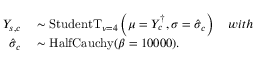Convert formula to latex. <formula><loc_0><loc_0><loc_500><loc_500>\begin{array} { r l } { Y _ { s , c } } & \sim S t u d e n t T _ { \nu = 4 } \left ( \mu = Y _ { c } ^ { \dagger } , \sigma = \hat { \sigma } _ { c } \right ) \quad w i t h } \\ { \hat { \sigma } _ { c } } & \sim H a l f C a u c h y ( \beta = 1 0 0 0 0 ) . } \end{array}</formula> 